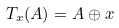<formula> <loc_0><loc_0><loc_500><loc_500>T _ { x } ( A ) = A \oplus x</formula> 